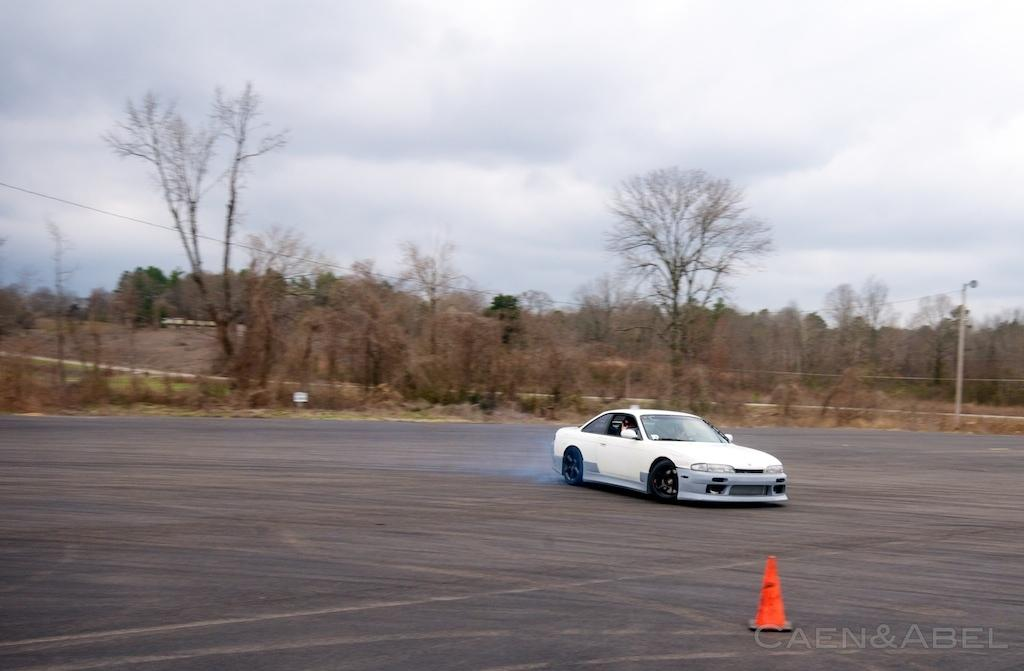What is on the road in the image? There is a car on the road in the image. What object can be seen near the road? There is a traffic cone in the image. What structure is present in the image? There is a pole in the image. What can be seen in the background of the image? Trees and the sky are visible in the background of the image. What is the condition of the sky in the image? Clouds are present in the sky. How many eggs are visible on the pole in the image? There are no eggs present in the image, and therefore no such objects can be observed on the pole. 